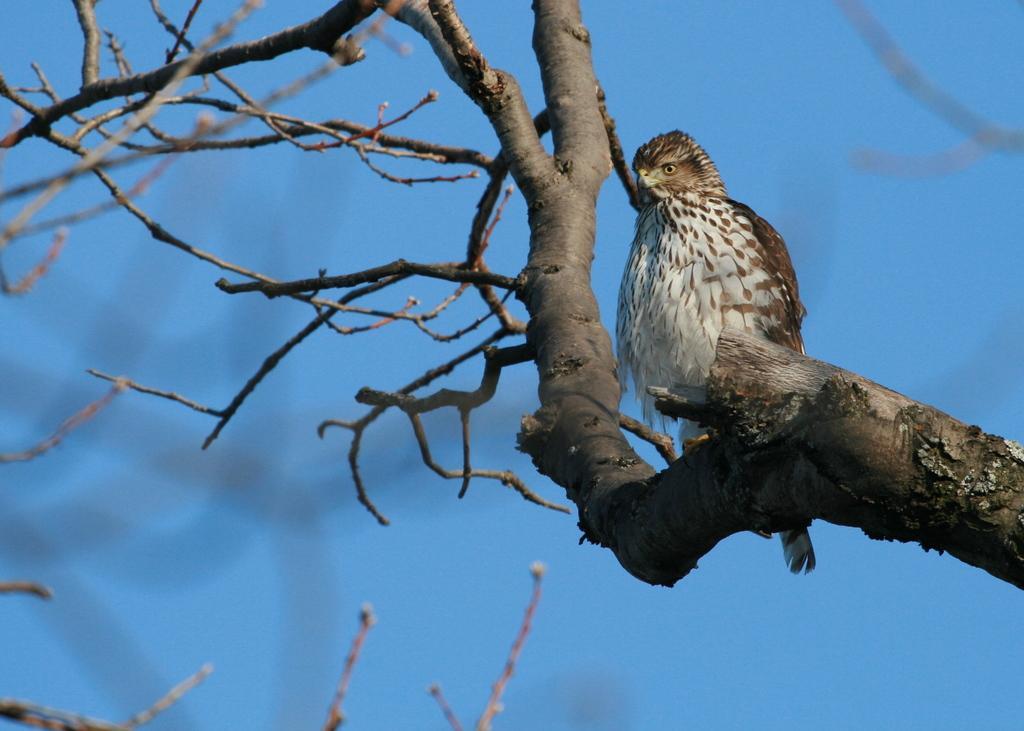How would you summarize this image in a sentence or two? In this image, we can see a bird on the branch of a tree and the background is blue in color. 